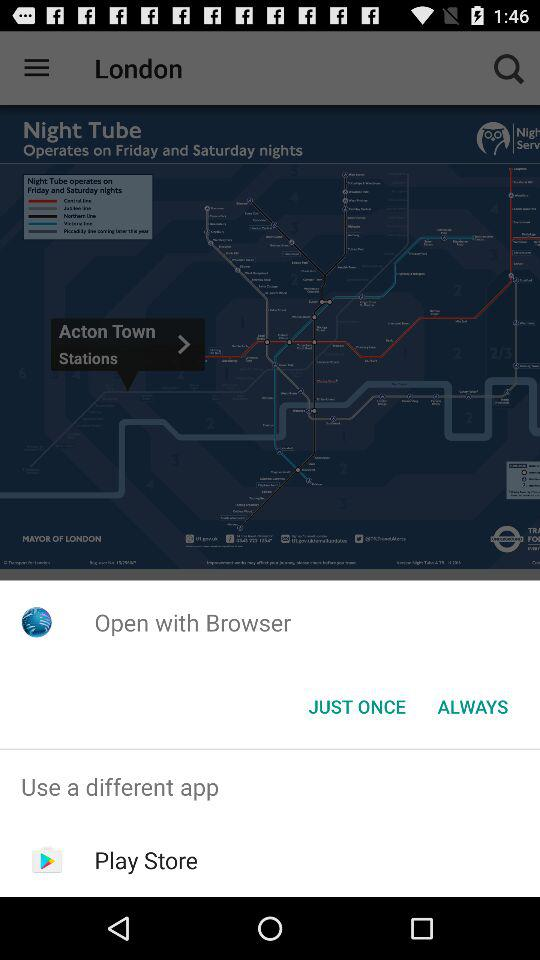Through what application can you "open with"? You can open with "Browser" and "Play Store". 